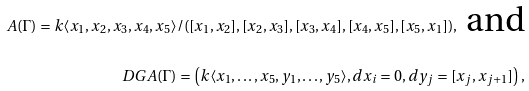<formula> <loc_0><loc_0><loc_500><loc_500>A ( \Gamma ) = k \langle x _ { 1 } , x _ { 2 } , x _ { 3 } , x _ { 4 } , x _ { 5 } \rangle / ( [ x _ { 1 } , x _ { 2 } ] , [ x _ { 2 } , x _ { 3 } ] , [ x _ { 3 } , x _ { 4 } ] , [ x _ { 4 } , x _ { 5 } ] , [ x _ { 5 } , x _ { 1 } ] ) , \text { and} \\ \ D G A ( \Gamma ) = \left ( k \langle x _ { 1 } , \dots , x _ { 5 } , y _ { 1 } , \dots , y _ { 5 } \rangle , d x _ { i } = 0 , d y _ { j } = [ x _ { j } , x _ { j + 1 } ] \right ) ,</formula> 